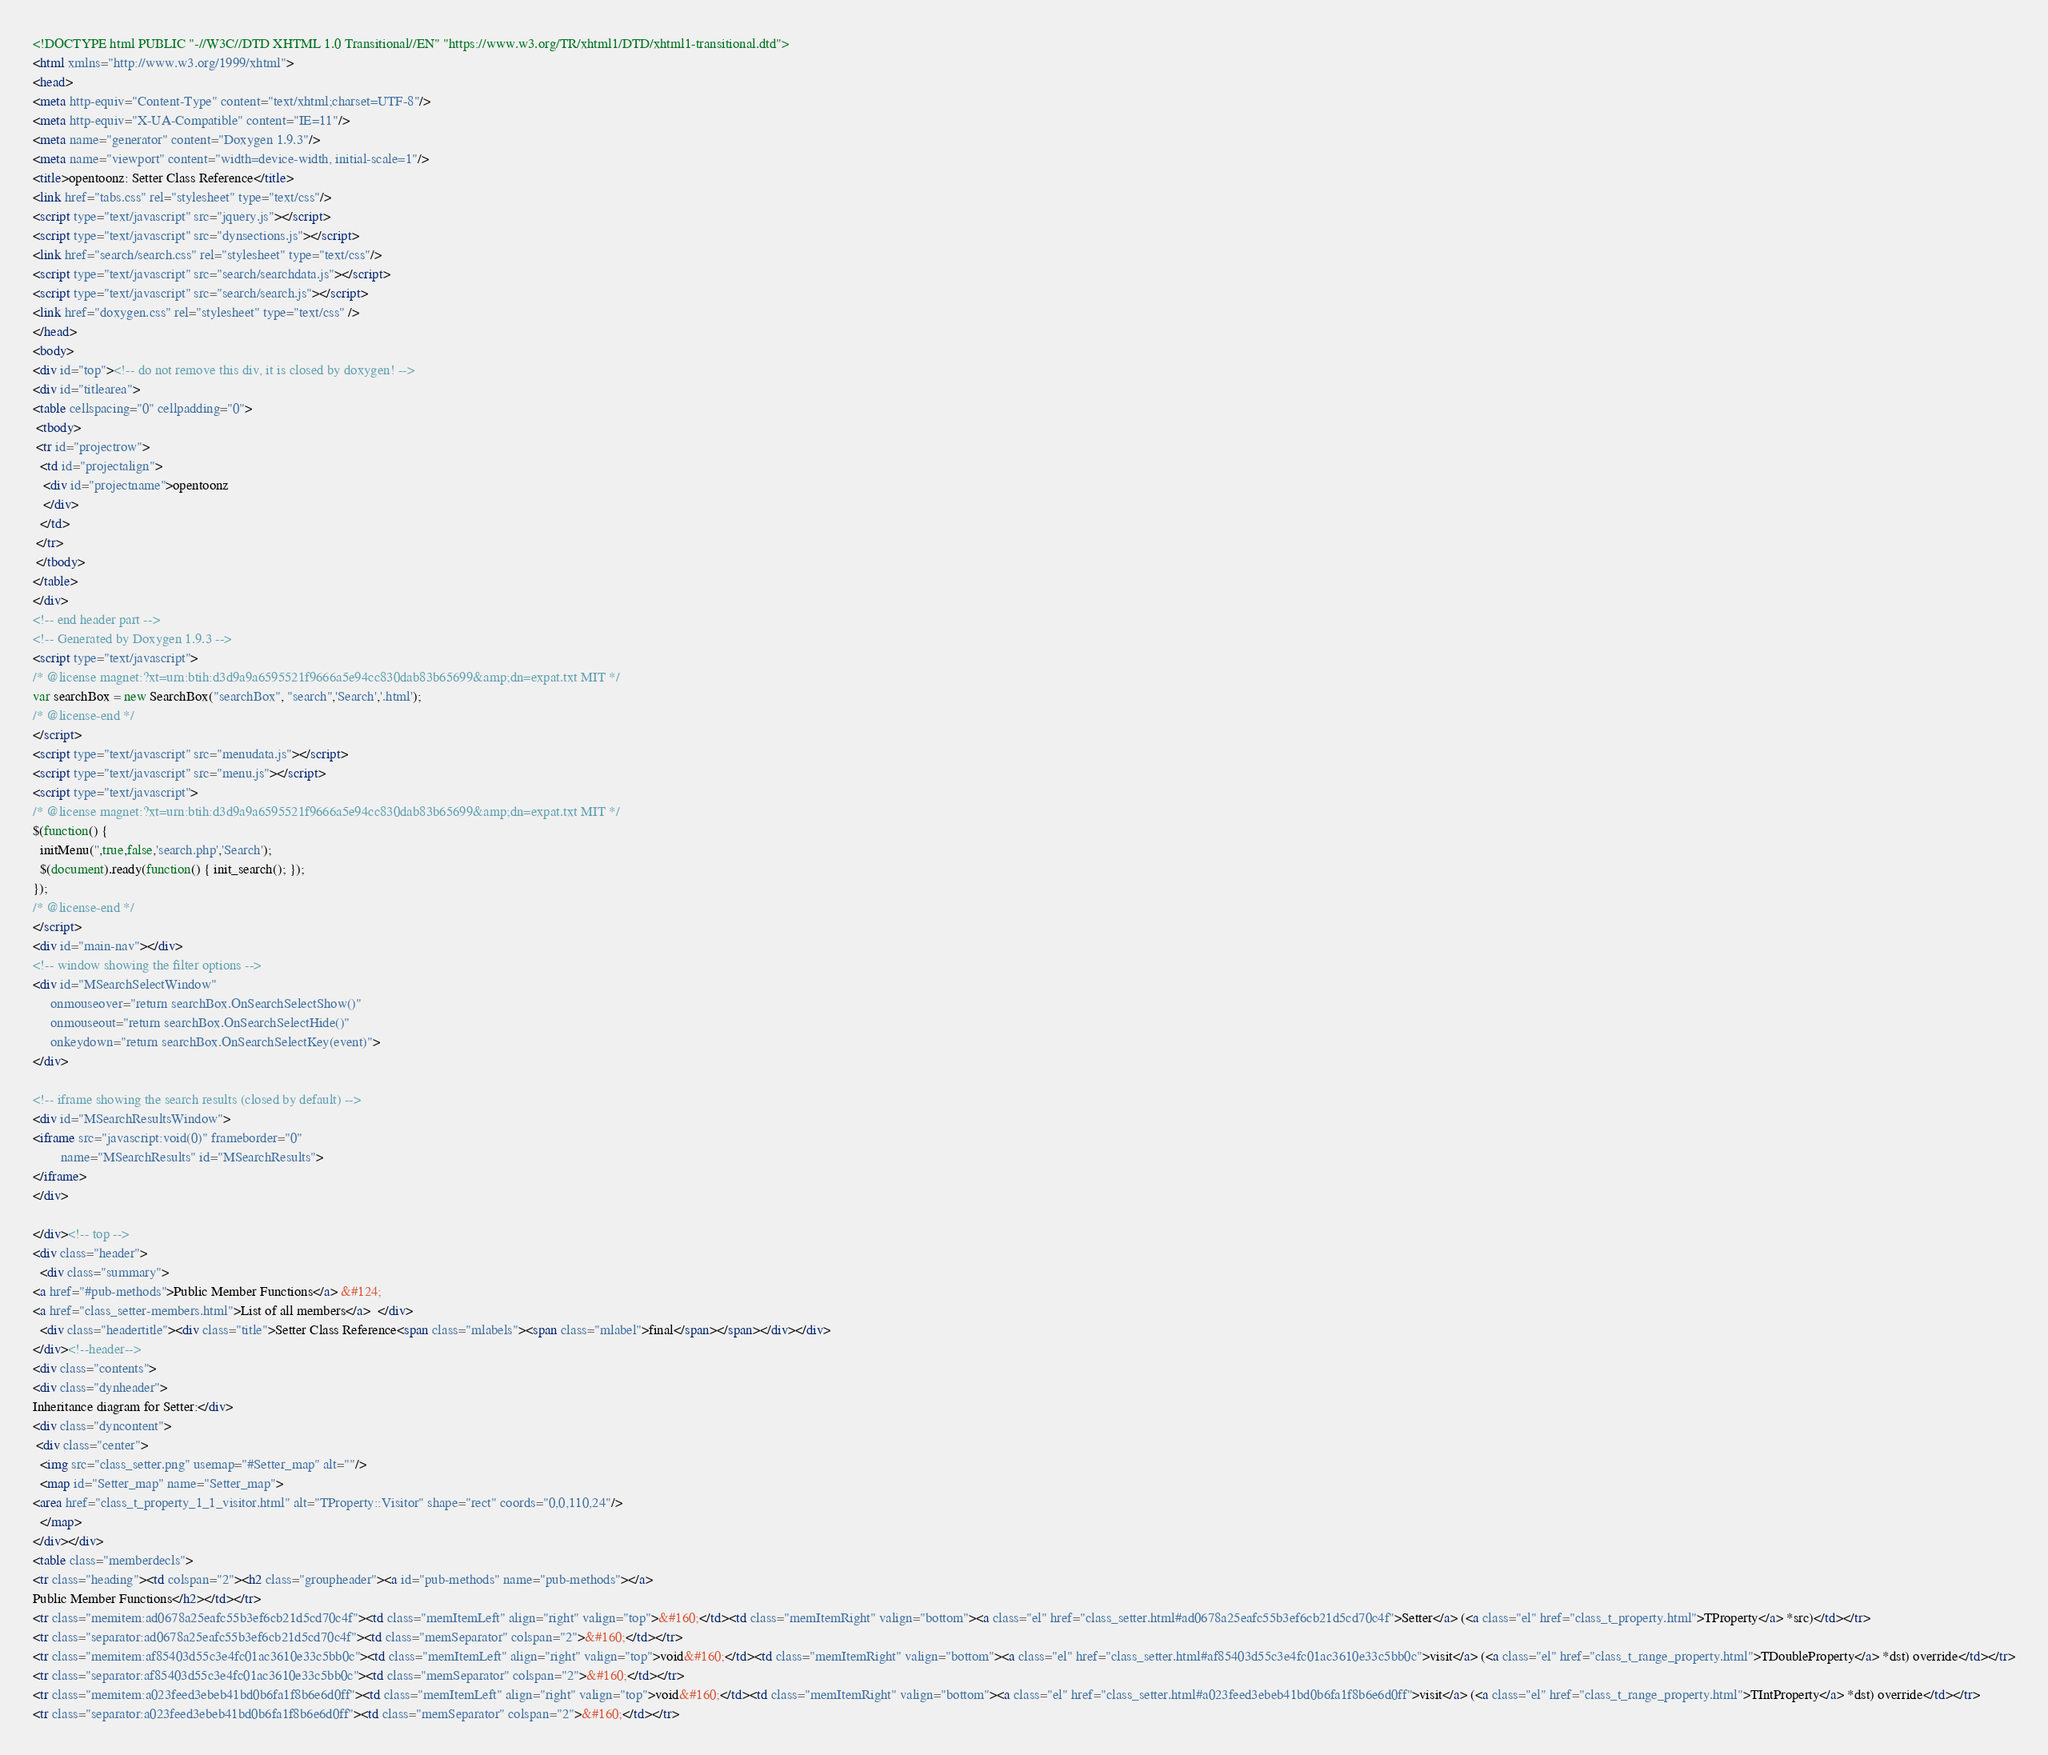Convert code to text. <code><loc_0><loc_0><loc_500><loc_500><_HTML_><!DOCTYPE html PUBLIC "-//W3C//DTD XHTML 1.0 Transitional//EN" "https://www.w3.org/TR/xhtml1/DTD/xhtml1-transitional.dtd">
<html xmlns="http://www.w3.org/1999/xhtml">
<head>
<meta http-equiv="Content-Type" content="text/xhtml;charset=UTF-8"/>
<meta http-equiv="X-UA-Compatible" content="IE=11"/>
<meta name="generator" content="Doxygen 1.9.3"/>
<meta name="viewport" content="width=device-width, initial-scale=1"/>
<title>opentoonz: Setter Class Reference</title>
<link href="tabs.css" rel="stylesheet" type="text/css"/>
<script type="text/javascript" src="jquery.js"></script>
<script type="text/javascript" src="dynsections.js"></script>
<link href="search/search.css" rel="stylesheet" type="text/css"/>
<script type="text/javascript" src="search/searchdata.js"></script>
<script type="text/javascript" src="search/search.js"></script>
<link href="doxygen.css" rel="stylesheet" type="text/css" />
</head>
<body>
<div id="top"><!-- do not remove this div, it is closed by doxygen! -->
<div id="titlearea">
<table cellspacing="0" cellpadding="0">
 <tbody>
 <tr id="projectrow">
  <td id="projectalign">
   <div id="projectname">opentoonz
   </div>
  </td>
 </tr>
 </tbody>
</table>
</div>
<!-- end header part -->
<!-- Generated by Doxygen 1.9.3 -->
<script type="text/javascript">
/* @license magnet:?xt=urn:btih:d3d9a9a6595521f9666a5e94cc830dab83b65699&amp;dn=expat.txt MIT */
var searchBox = new SearchBox("searchBox", "search",'Search','.html');
/* @license-end */
</script>
<script type="text/javascript" src="menudata.js"></script>
<script type="text/javascript" src="menu.js"></script>
<script type="text/javascript">
/* @license magnet:?xt=urn:btih:d3d9a9a6595521f9666a5e94cc830dab83b65699&amp;dn=expat.txt MIT */
$(function() {
  initMenu('',true,false,'search.php','Search');
  $(document).ready(function() { init_search(); });
});
/* @license-end */
</script>
<div id="main-nav"></div>
<!-- window showing the filter options -->
<div id="MSearchSelectWindow"
     onmouseover="return searchBox.OnSearchSelectShow()"
     onmouseout="return searchBox.OnSearchSelectHide()"
     onkeydown="return searchBox.OnSearchSelectKey(event)">
</div>

<!-- iframe showing the search results (closed by default) -->
<div id="MSearchResultsWindow">
<iframe src="javascript:void(0)" frameborder="0" 
        name="MSearchResults" id="MSearchResults">
</iframe>
</div>

</div><!-- top -->
<div class="header">
  <div class="summary">
<a href="#pub-methods">Public Member Functions</a> &#124;
<a href="class_setter-members.html">List of all members</a>  </div>
  <div class="headertitle"><div class="title">Setter Class Reference<span class="mlabels"><span class="mlabel">final</span></span></div></div>
</div><!--header-->
<div class="contents">
<div class="dynheader">
Inheritance diagram for Setter:</div>
<div class="dyncontent">
 <div class="center">
  <img src="class_setter.png" usemap="#Setter_map" alt=""/>
  <map id="Setter_map" name="Setter_map">
<area href="class_t_property_1_1_visitor.html" alt="TProperty::Visitor" shape="rect" coords="0,0,110,24"/>
  </map>
</div></div>
<table class="memberdecls">
<tr class="heading"><td colspan="2"><h2 class="groupheader"><a id="pub-methods" name="pub-methods"></a>
Public Member Functions</h2></td></tr>
<tr class="memitem:ad0678a25eafc55b3ef6cb21d5cd70c4f"><td class="memItemLeft" align="right" valign="top">&#160;</td><td class="memItemRight" valign="bottom"><a class="el" href="class_setter.html#ad0678a25eafc55b3ef6cb21d5cd70c4f">Setter</a> (<a class="el" href="class_t_property.html">TProperty</a> *src)</td></tr>
<tr class="separator:ad0678a25eafc55b3ef6cb21d5cd70c4f"><td class="memSeparator" colspan="2">&#160;</td></tr>
<tr class="memitem:af85403d55c3e4fc01ac3610e33c5bb0c"><td class="memItemLeft" align="right" valign="top">void&#160;</td><td class="memItemRight" valign="bottom"><a class="el" href="class_setter.html#af85403d55c3e4fc01ac3610e33c5bb0c">visit</a> (<a class="el" href="class_t_range_property.html">TDoubleProperty</a> *dst) override</td></tr>
<tr class="separator:af85403d55c3e4fc01ac3610e33c5bb0c"><td class="memSeparator" colspan="2">&#160;</td></tr>
<tr class="memitem:a023feed3ebeb41bd0b6fa1f8b6e6d0ff"><td class="memItemLeft" align="right" valign="top">void&#160;</td><td class="memItemRight" valign="bottom"><a class="el" href="class_setter.html#a023feed3ebeb41bd0b6fa1f8b6e6d0ff">visit</a> (<a class="el" href="class_t_range_property.html">TIntProperty</a> *dst) override</td></tr>
<tr class="separator:a023feed3ebeb41bd0b6fa1f8b6e6d0ff"><td class="memSeparator" colspan="2">&#160;</td></tr></code> 